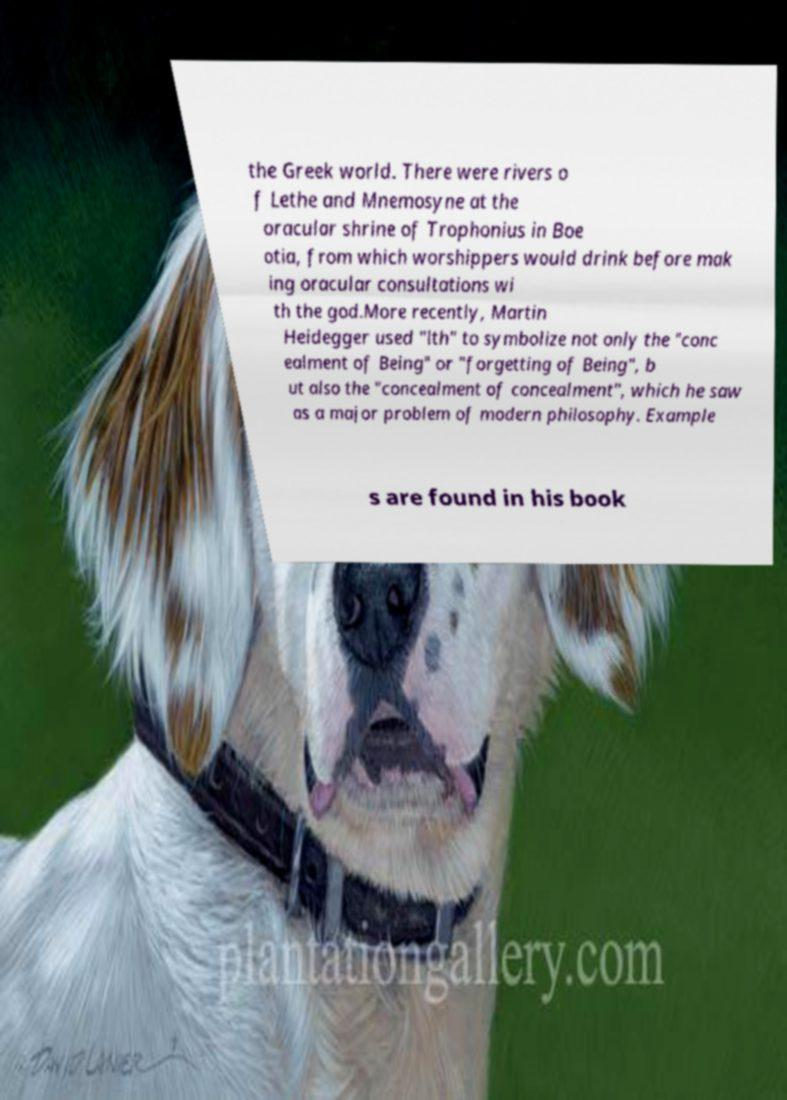Can you read and provide the text displayed in the image?This photo seems to have some interesting text. Can you extract and type it out for me? the Greek world. There were rivers o f Lethe and Mnemosyne at the oracular shrine of Trophonius in Boe otia, from which worshippers would drink before mak ing oracular consultations wi th the god.More recently, Martin Heidegger used "lth" to symbolize not only the "conc ealment of Being" or "forgetting of Being", b ut also the "concealment of concealment", which he saw as a major problem of modern philosophy. Example s are found in his book 